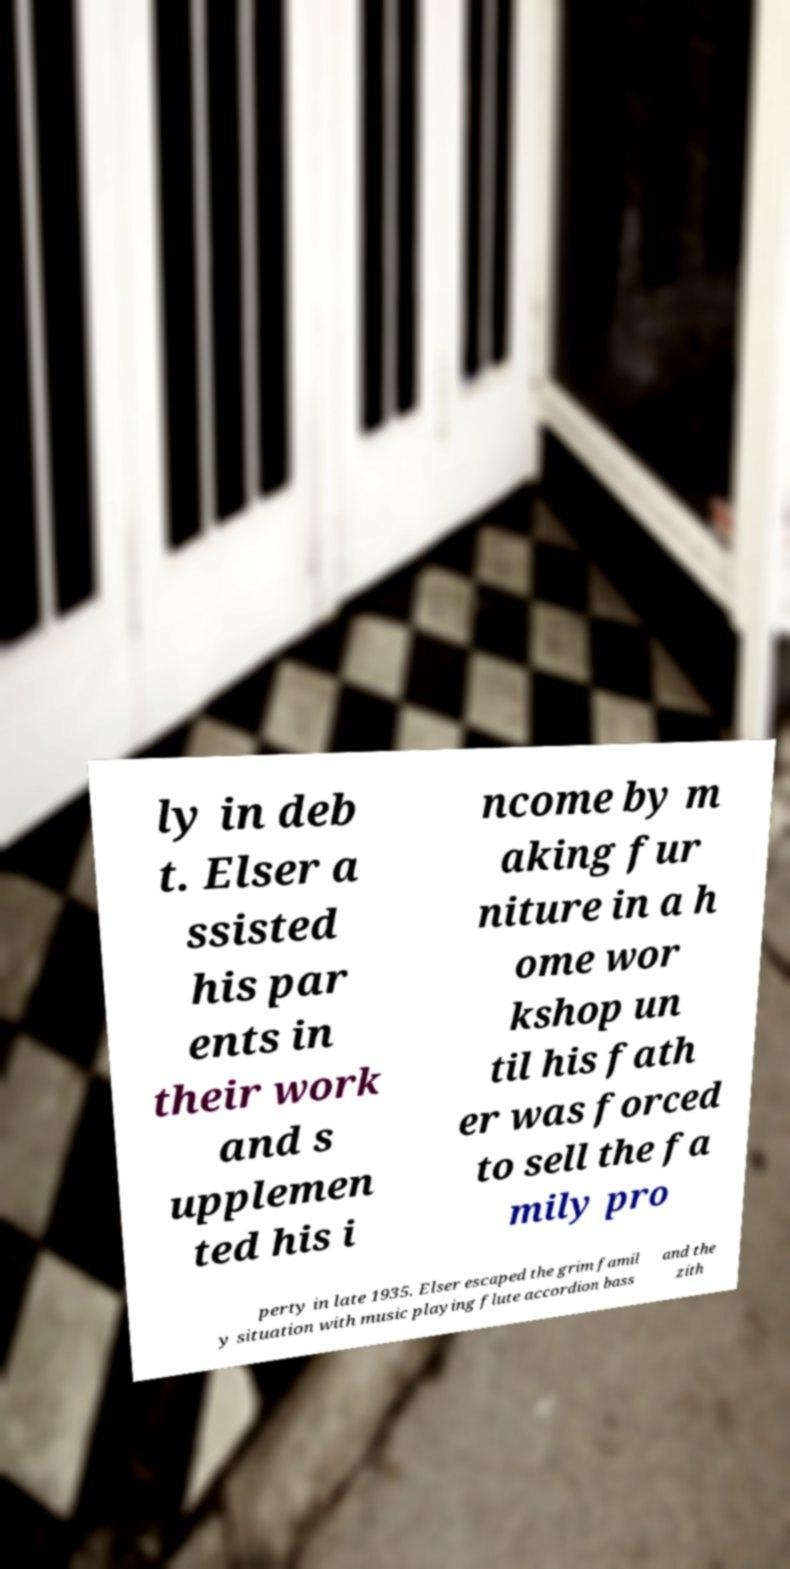Can you read and provide the text displayed in the image?This photo seems to have some interesting text. Can you extract and type it out for me? ly in deb t. Elser a ssisted his par ents in their work and s upplemen ted his i ncome by m aking fur niture in a h ome wor kshop un til his fath er was forced to sell the fa mily pro perty in late 1935. Elser escaped the grim famil y situation with music playing flute accordion bass and the zith 